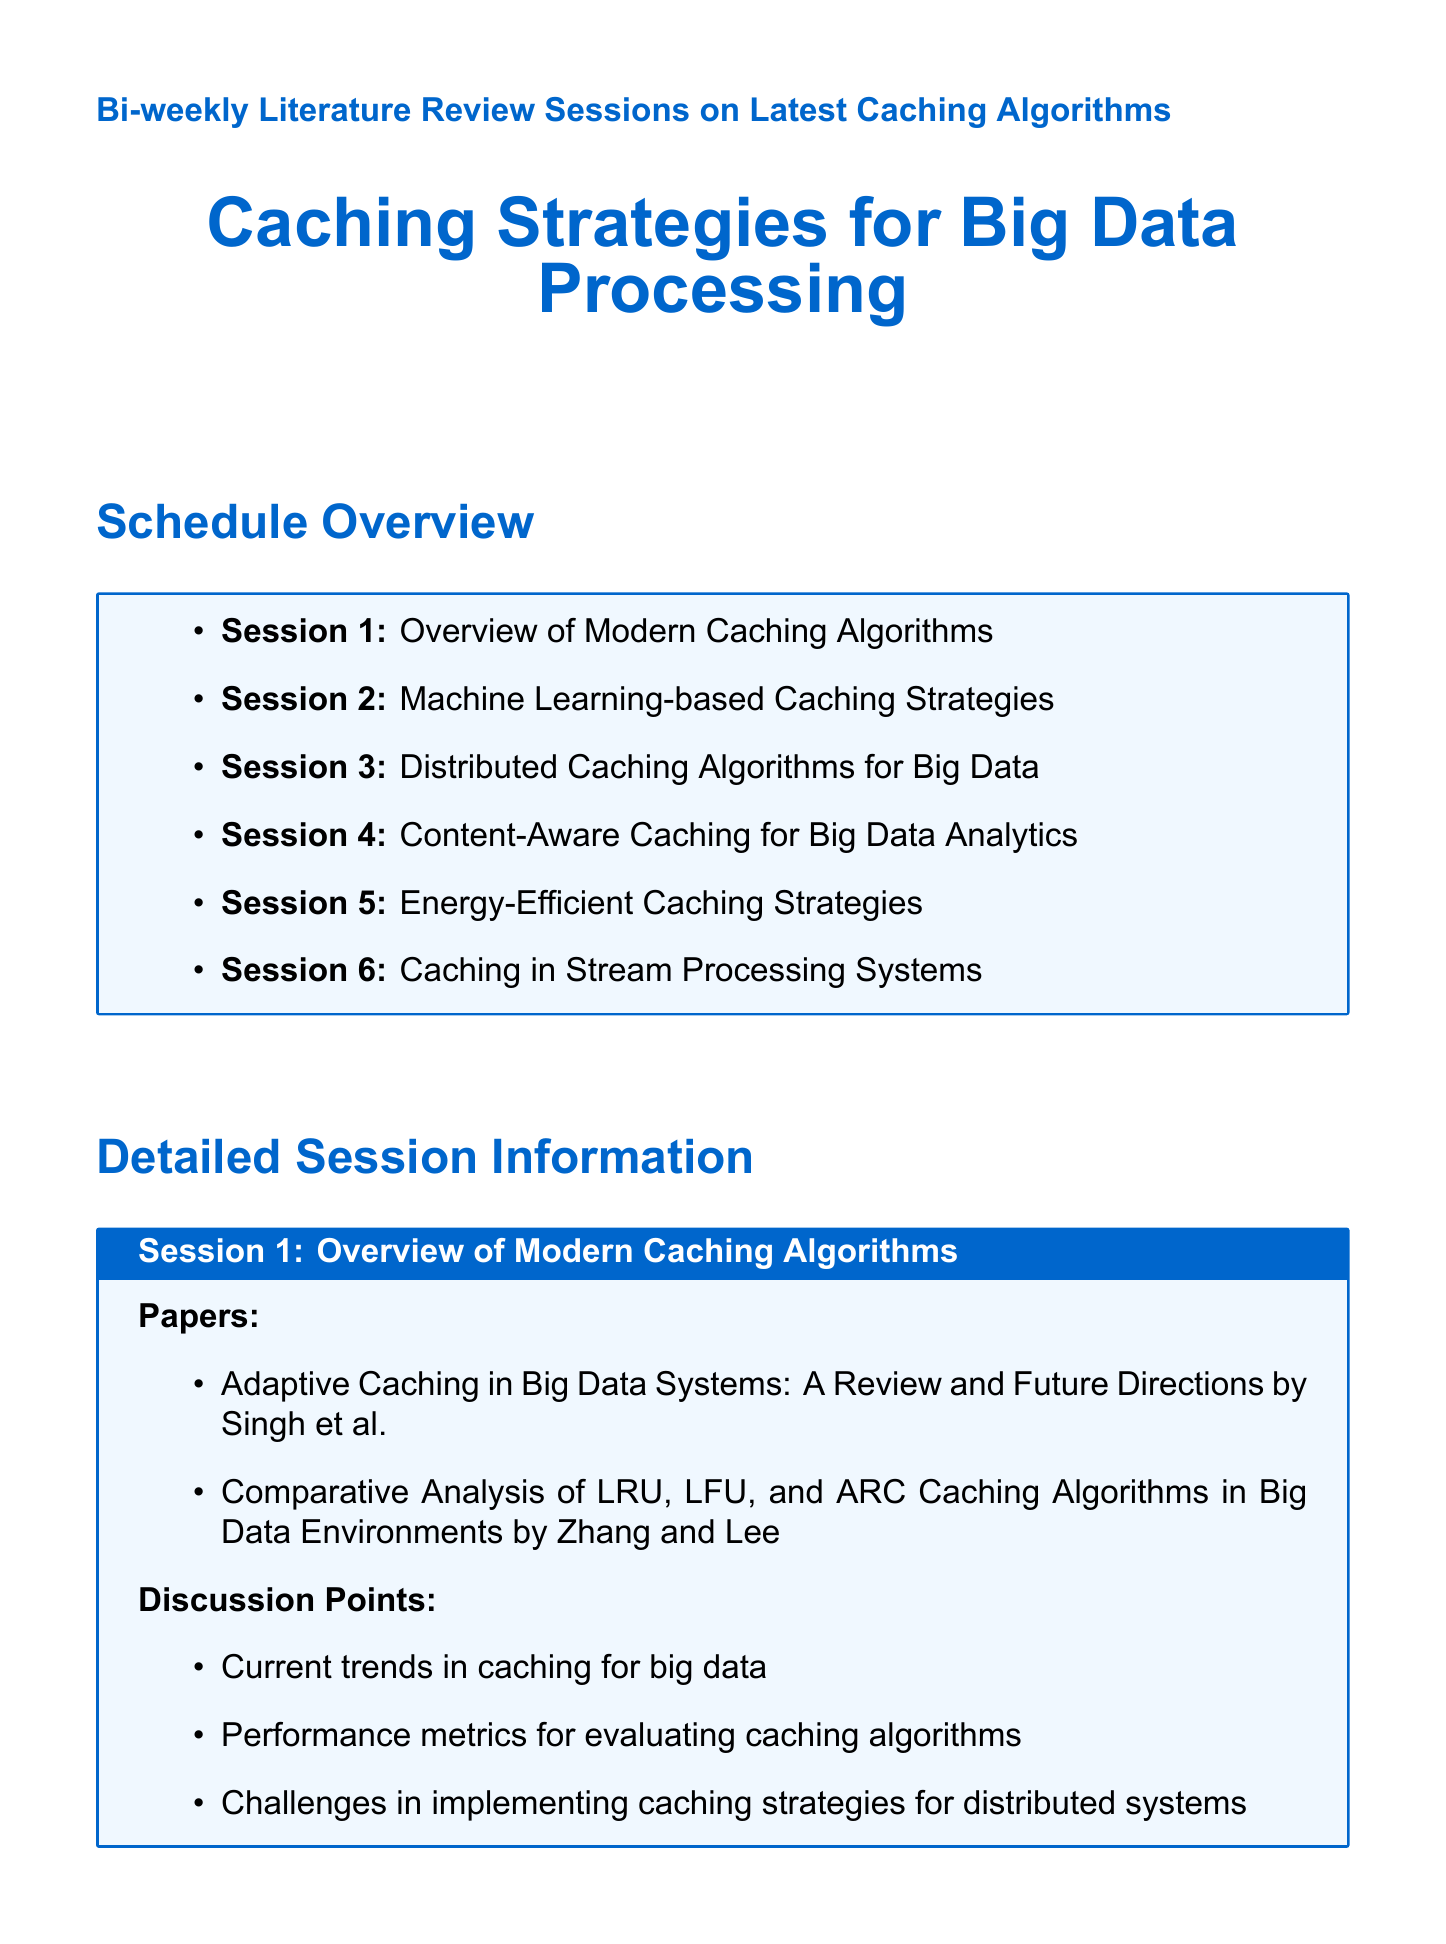what is the title of session 1? The title of session 1 is provided in the document under "Session 1", which states "Overview of Modern Caching Algorithms".
Answer: Overview of Modern Caching Algorithms who are the authors of the second paper in session 4? The authors of the second paper listed in session 4 are mentioned in the title of that paper, which states "Semantic-based Caching for SPARQL Query Optimization in Big RDF Data by Chen and Wu".
Answer: Chen and Wu how many sessions are scheduled in total? The document lists a total of six sessions in the Schedule Overview section.
Answer: 6 what is the main topic of session 5? Session 5’s main topic is stated as "Energy-Efficient Caching Strategies".
Answer: Energy-Efficient Caching Strategies what is a discussion point in session 2? One of the discussion points for session 2 can be found in the list provided for that session, specifically "Integration of ML models with existing caching systems".
Answer: Integration of ML models with existing caching systems who presented the paper in session 3 about cooperative caching? The author of the paper on cooperative caching is described in the document as "Sharma and Brown".
Answer: Sharma and Brown what is the focus of session 6? The focus of session 6 is outlined as "Caching in Stream Processing Systems".
Answer: Caching in Stream Processing Systems how many discussion points are listed for session 5? The document indicates there are three discussion points listed for session 5 under the discussion points section.
Answer: 3 